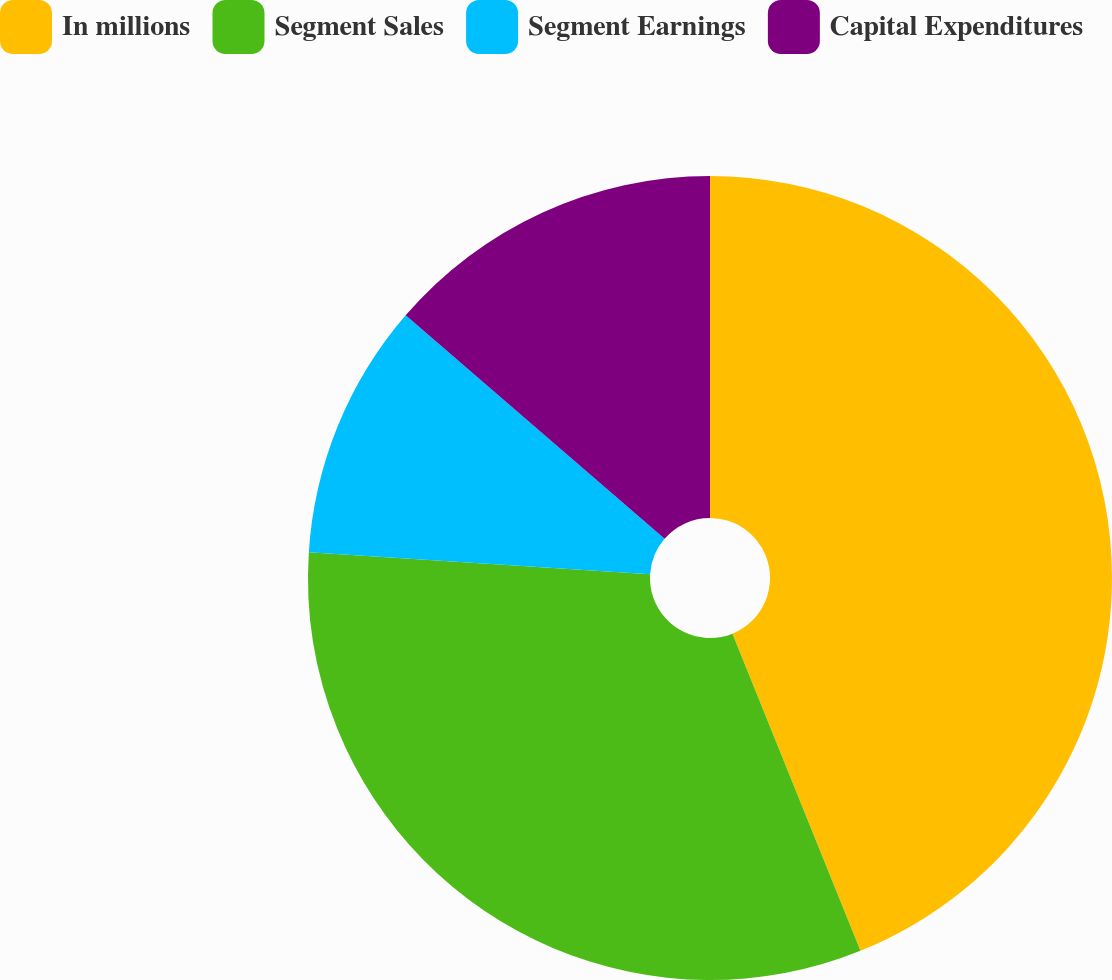<chart> <loc_0><loc_0><loc_500><loc_500><pie_chart><fcel>In millions<fcel>Segment Sales<fcel>Segment Earnings<fcel>Capital Expenditures<nl><fcel>43.9%<fcel>32.13%<fcel>10.31%<fcel>13.67%<nl></chart> 